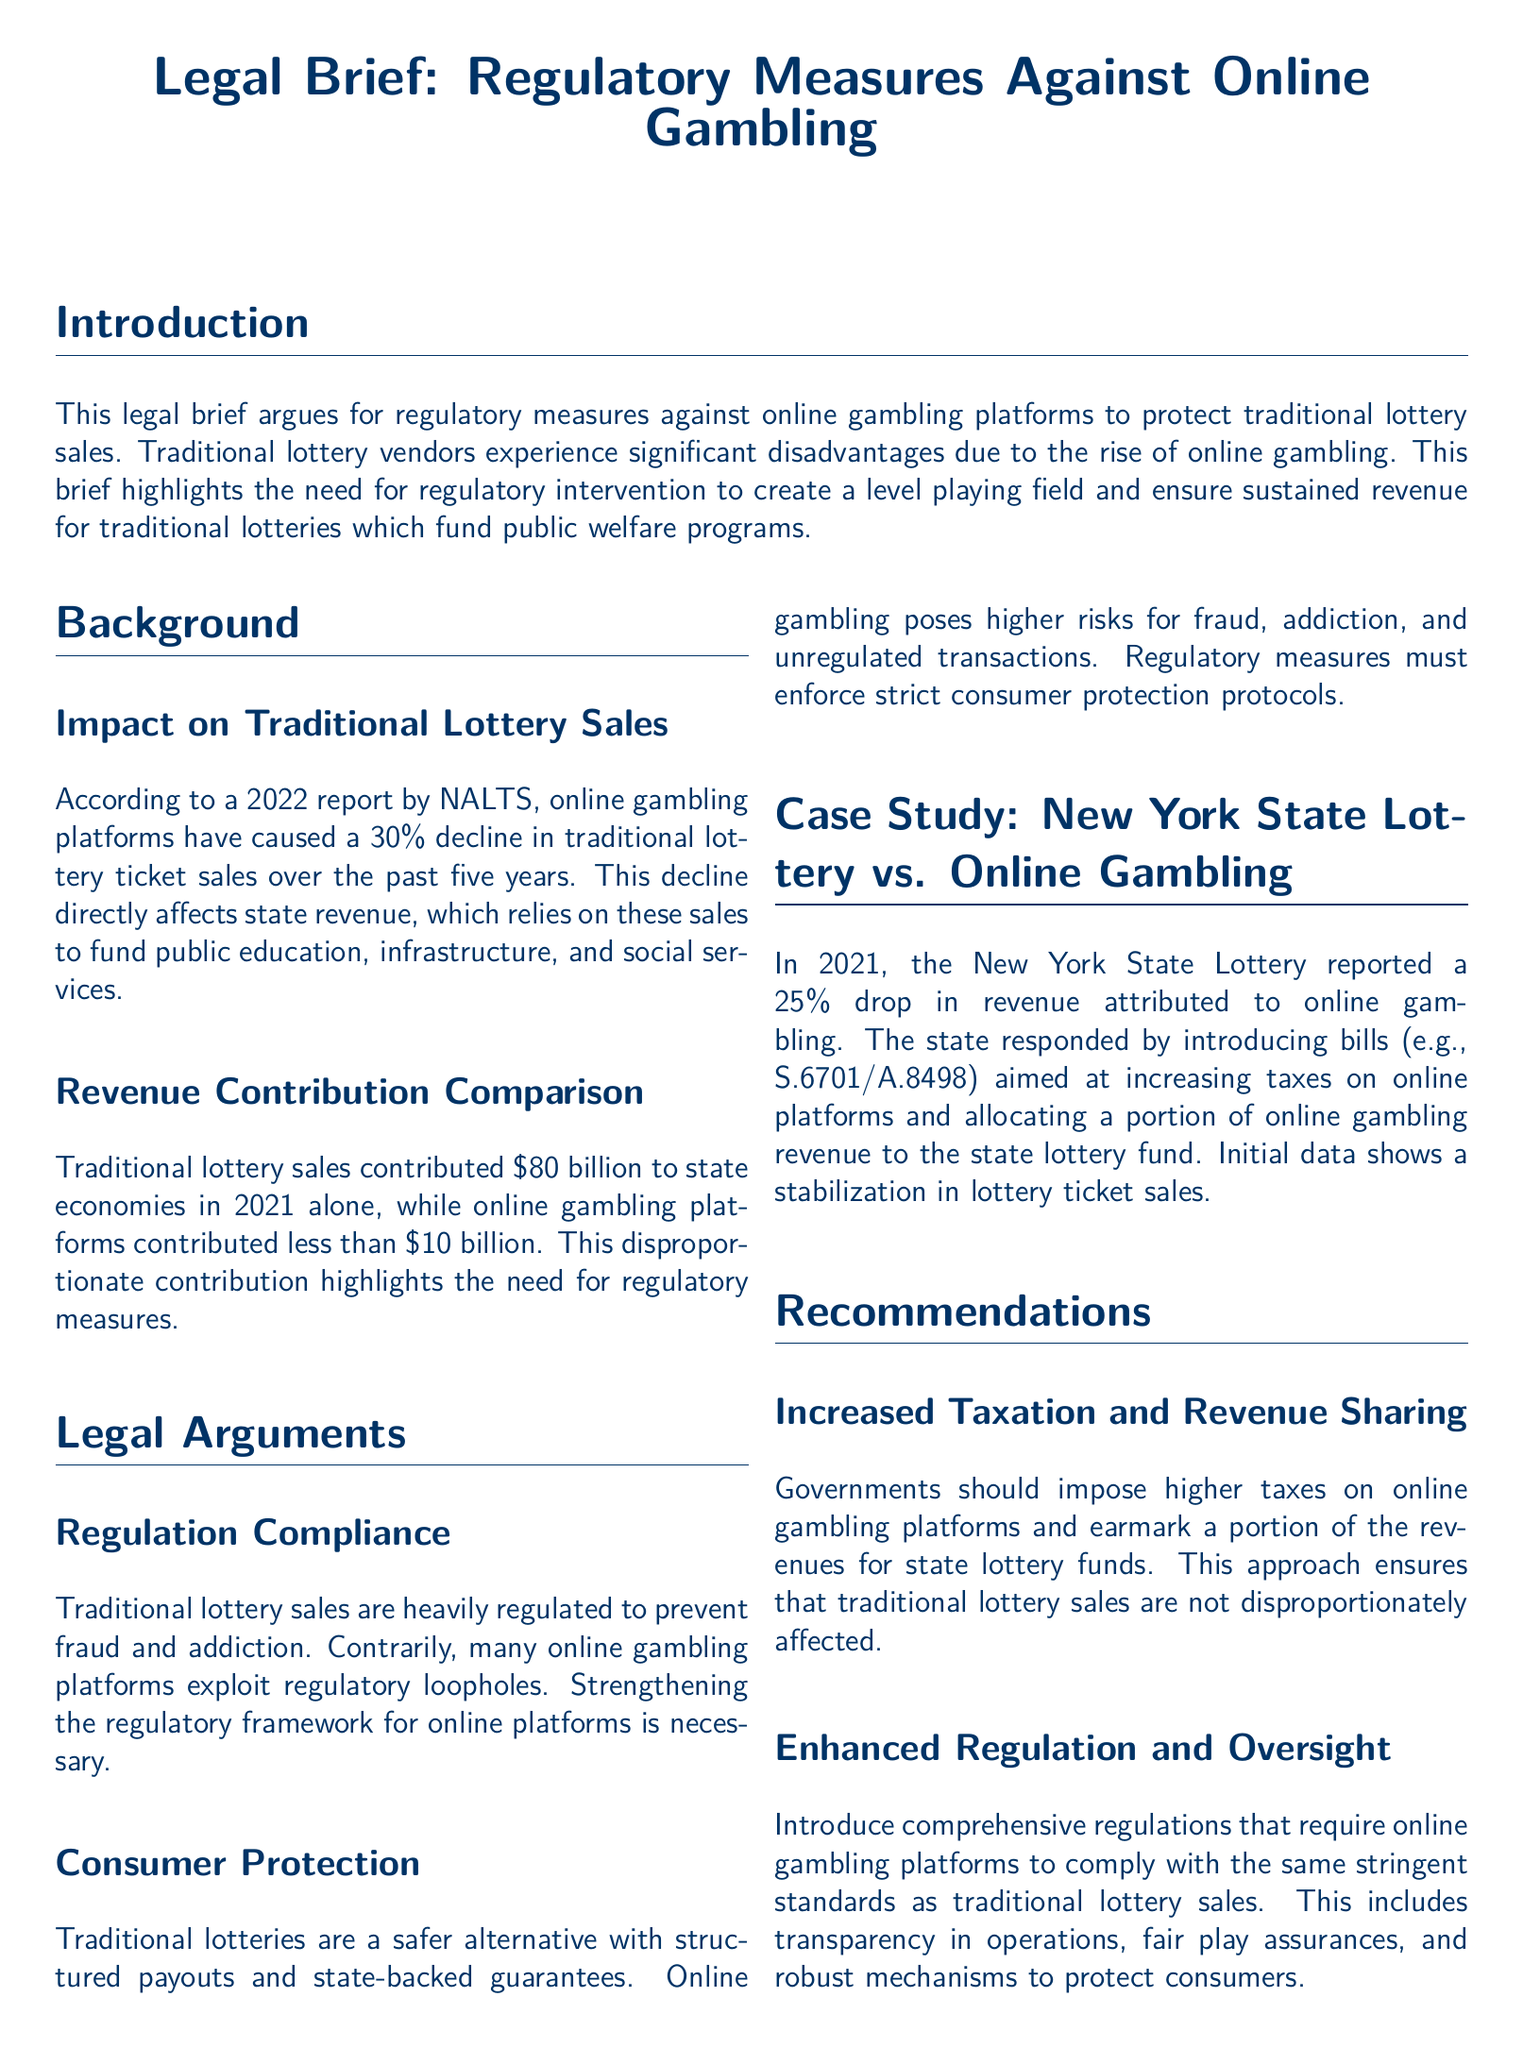what percentage decline in traditional lottery sales was reported? According to the report by NALTS, online gambling platforms have caused a 30% decline in traditional lottery ticket sales.
Answer: 30% what was the revenue contribution of traditional lottery sales in 2021? The document states that traditional lottery sales contributed $80 billion to state economies in 2021.
Answer: $80 billion what is one of the main reasons traditional lotteries are considered safer? The brief mentions that traditional lotteries have structured payouts and state-backed guarantees, making them safer.
Answer: structured payouts which state reported a 25% drop in revenue due to online gambling? The document cites New York State Lottery as the entity that reported a 25% drop in revenue attributed to online gambling.
Answer: New York State what is a recommended action for governments regarding online gambling platforms? The document recommends that governments impose higher taxes on online gambling platforms.
Answer: higher taxes how much did online gambling platforms contribute in comparison to traditional lottery sales? The brief compares that online gambling platforms contributed less than $10 billion, while traditional lottery sales contributed much more.
Answer: less than $10 billion what type of protocols should be enforced for consumer protection? The brief calls for regulatory measures to enforce strict consumer protection protocols for online gambling platforms.
Answer: strict consumer protection protocols what was one legislative response to the revenue drop in the New York State Lottery? The document mentions the introduction of bills aimed at increasing taxes on online platforms as a legislative response.
Answer: increasing taxes which organization conducted the report stating the impact on lottery ticket sales? The report stating the impact on traditional lottery sales was conducted by NALTS.
Answer: NALTS 